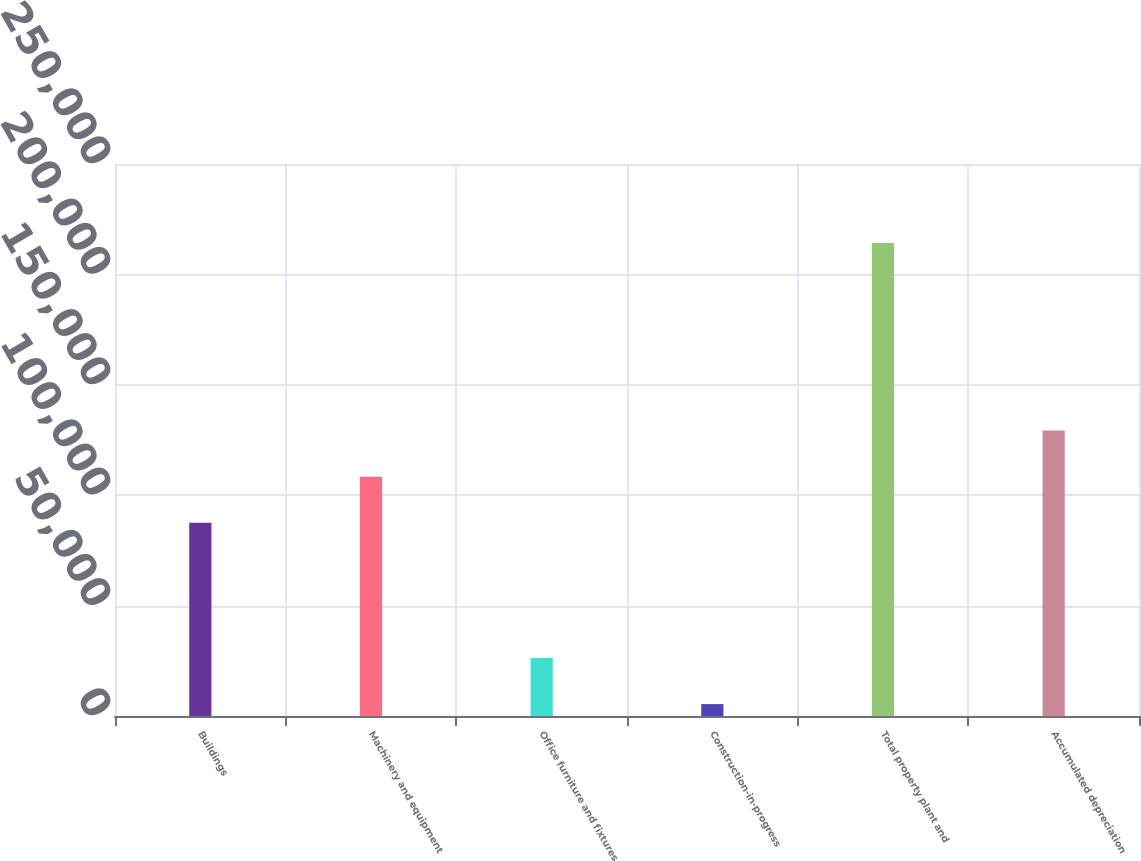Convert chart to OTSL. <chart><loc_0><loc_0><loc_500><loc_500><bar_chart><fcel>Buildings<fcel>Machinery and equipment<fcel>Office furniture and fixtures<fcel>Construction-in-progress<fcel>Total property plant and<fcel>Accumulated depreciation<nl><fcel>87492<fcel>108376<fcel>26276.2<fcel>5392<fcel>214234<fcel>129260<nl></chart> 